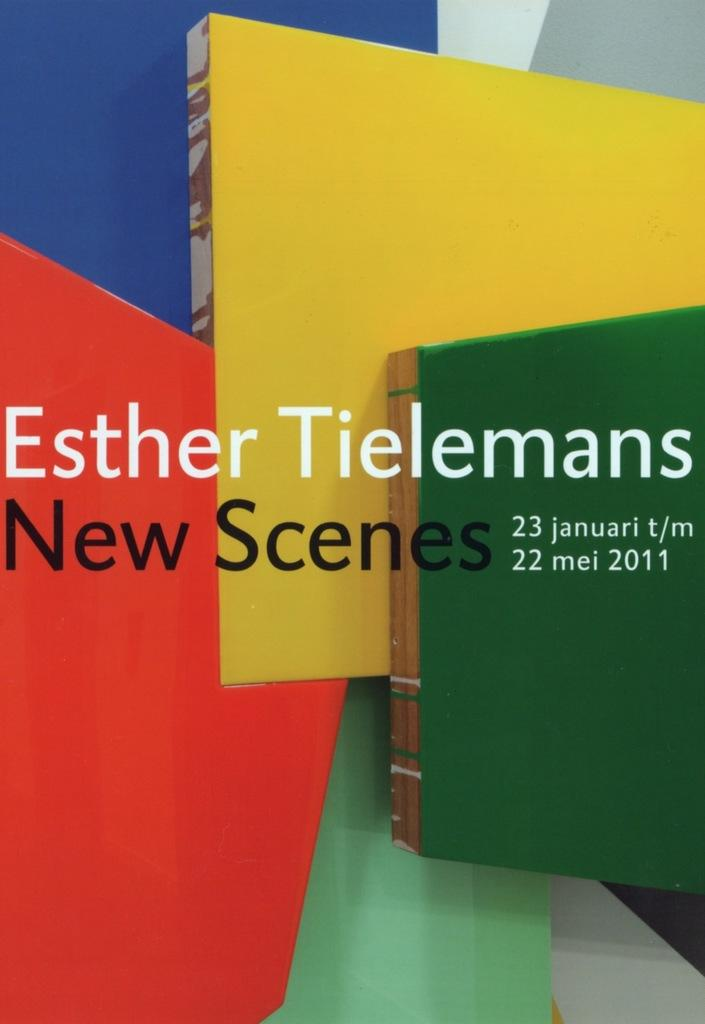<image>
Relay a brief, clear account of the picture shown. The show of Esther Tielemans opens January 23. 